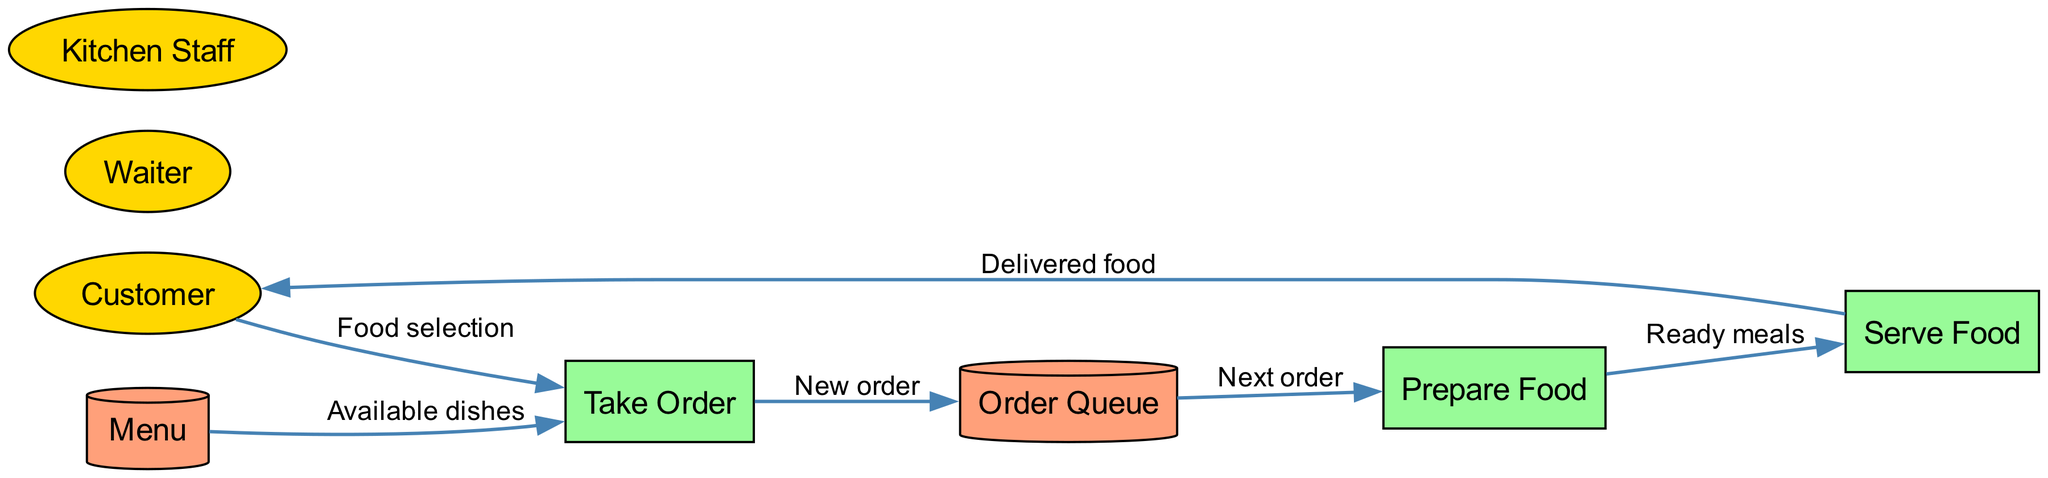What are the external entities in the diagram? The external entities represented in the diagram include the Customer, Waiter, and Kitchen Staff. These entities are shown as ellipses in the diagram, denoting their role outside the main processes of the order flow.
Answer: Customer, Waiter, Kitchen Staff How many processes are in the diagram? The diagram contains three processes: Take Order, Prepare Food, and Serve Food. These are illustrated as rectangles, showing the major steps involved in the restaurant order flow.
Answer: 3 Which process handles the food selection? The "Take Order" process is responsible for handling food selection. This is indicated by the flow from the Customer to the Take Order, labeled as "Food selection."
Answer: Take Order What is the data store used for storing orders? The data store named "Order Queue" is used for storing orders. It receives data from the "Take Order" process and provides data to the "Prepare Food" process.
Answer: Order Queue What type of flow is shown between "Prepare Food" and "Serve Food"? The flow between "Prepare Food" and "Serve Food" is labeled as "Ready meals." This indicates that food that is ready from the kitchen is passed to the serving process.
Answer: Ready meals How does a customer receive their food? A customer receives their food through the "Serve Food" process, which delivers food back to them, as indicated by the flow labeled "Delivered food."
Answer: Delivered food Which entity provides the available dishes to the order process? The entity providing the available dishes to the "Take Order" process is the "Menu." This is shown in the diagram where the flow is directed from the Menu to Take Order, labeled as "Available dishes."
Answer: Menu What is the first step in the order flow? The first step in the order flow is "Take Order." This process begins the sequence by taking the customer's food selection before any preparation occurs.
Answer: Take Order How many edges are there in total in the diagram? The diagram has six edges, which represent the various data flows between the external entities, processes, and data stores. Each flow is a directional connection that is illustrated in the diagram.
Answer: 6 